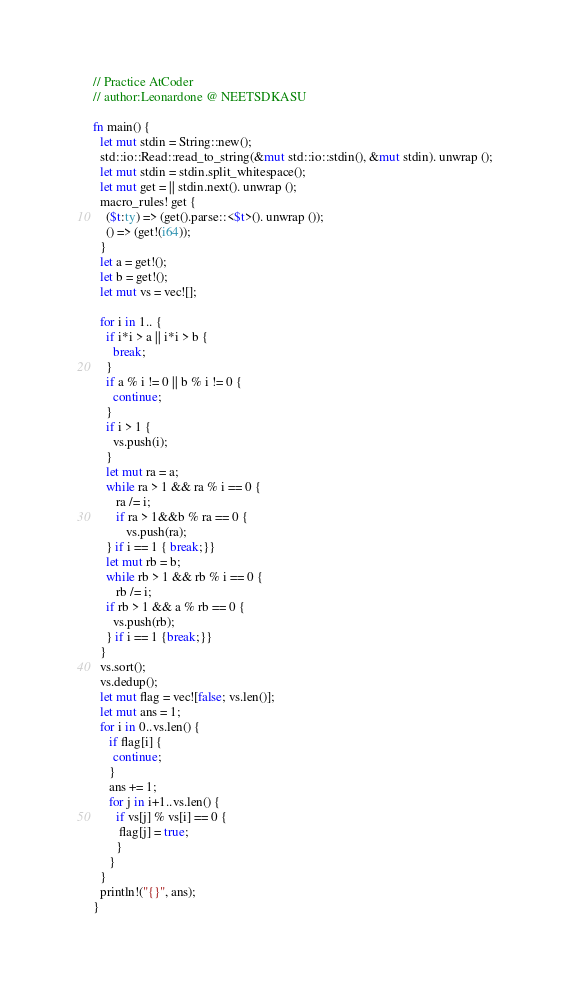<code> <loc_0><loc_0><loc_500><loc_500><_Rust_>// Practice AtCoder
// author:Leonardone @ NEETSDKASU

fn main() {
  let mut stdin = String::new();
  std::io::Read::read_to_string(&mut std::io::stdin(), &mut stdin). unwrap ();
  let mut stdin = stdin.split_whitespace();
  let mut get = || stdin.next(). unwrap ();
  macro_rules! get {
    ($t:ty) => (get().parse::<$t>(). unwrap ());
    () => (get!(i64));
  }
  let a = get!();
  let b = get!();
  let mut vs = vec![];
   
  for i in 1.. {
    if i*i > a || i*i > b {
      break;
    }
    if a % i != 0 || b % i != 0 {
      continue;
    }
    if i > 1 {
      vs.push(i);
    }
    let mut ra = a;
    while ra > 1 && ra % i == 0 {
       ra /= i;
       if ra > 1&&b % ra == 0 {
          vs.push(ra);
    } if i == 1 { break;}}
    let mut rb = b;
    while rb > 1 && rb % i == 0 {
       rb /= i;
    if rb > 1 && a % rb == 0 { 
      vs.push(rb);
    } if i == 1 {break;}}
  }
  vs.sort(); 
  vs.dedup();
  let mut flag = vec![false; vs.len()];
  let mut ans = 1;
  for i in 0..vs.len() {
     if flag[i] {
      continue;
     }
     ans += 1;
     for j in i+1..vs.len() {
       if vs[j] % vs[i] == 0 { 
        flag[j] = true;
       }
     }
  }
  println!("{}", ans);
}</code> 